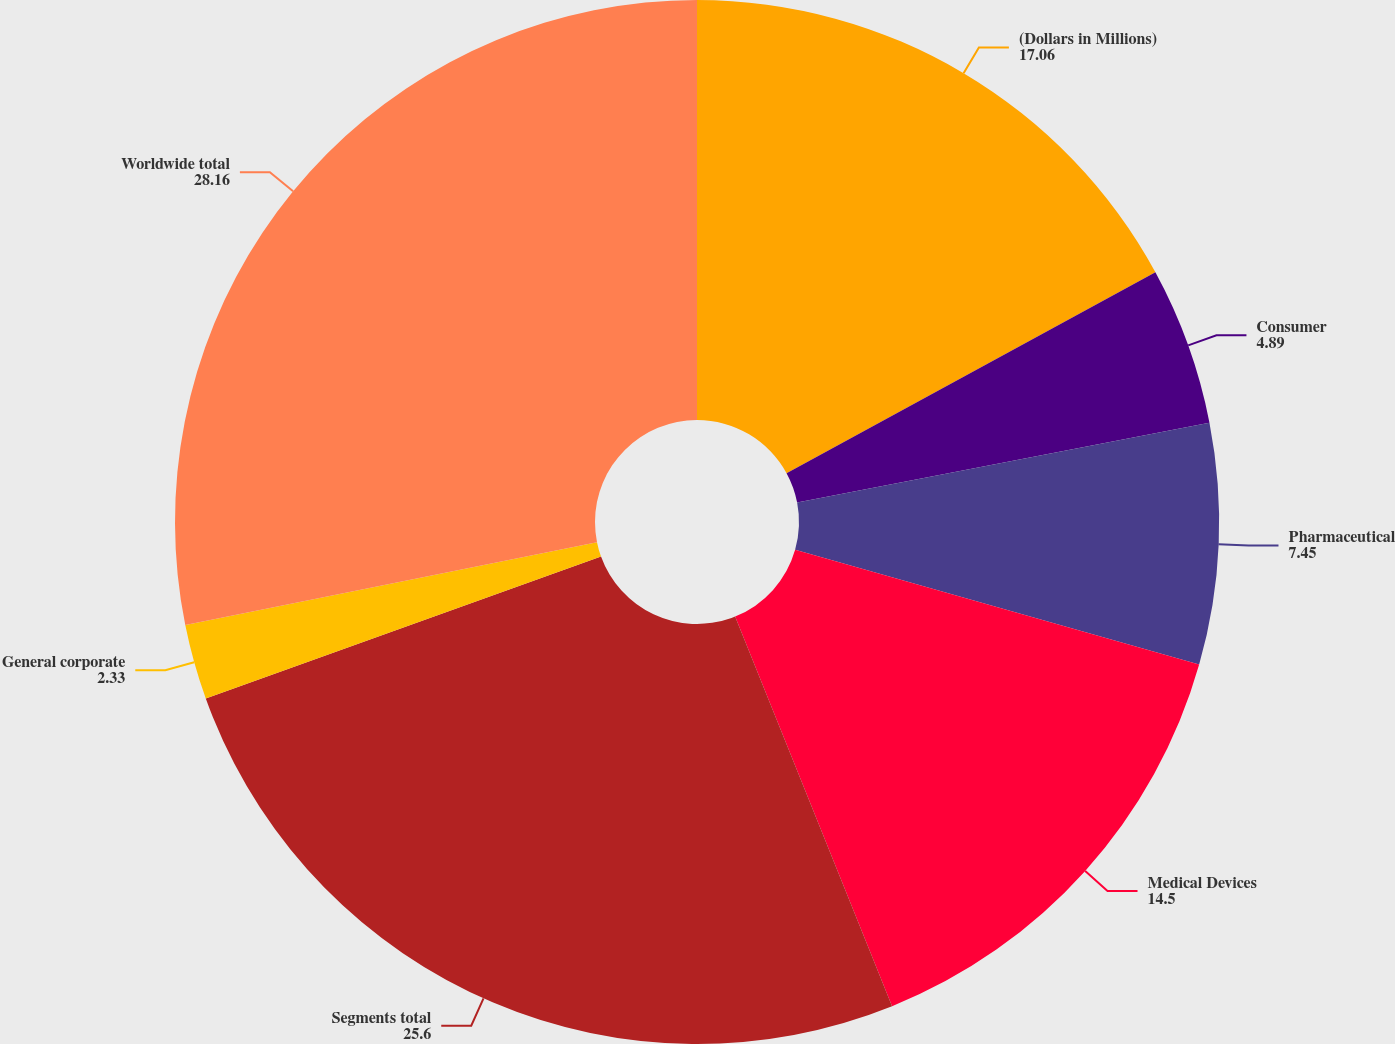<chart> <loc_0><loc_0><loc_500><loc_500><pie_chart><fcel>(Dollars in Millions)<fcel>Consumer<fcel>Pharmaceutical<fcel>Medical Devices<fcel>Segments total<fcel>General corporate<fcel>Worldwide total<nl><fcel>17.06%<fcel>4.89%<fcel>7.45%<fcel>14.5%<fcel>25.6%<fcel>2.33%<fcel>28.16%<nl></chart> 